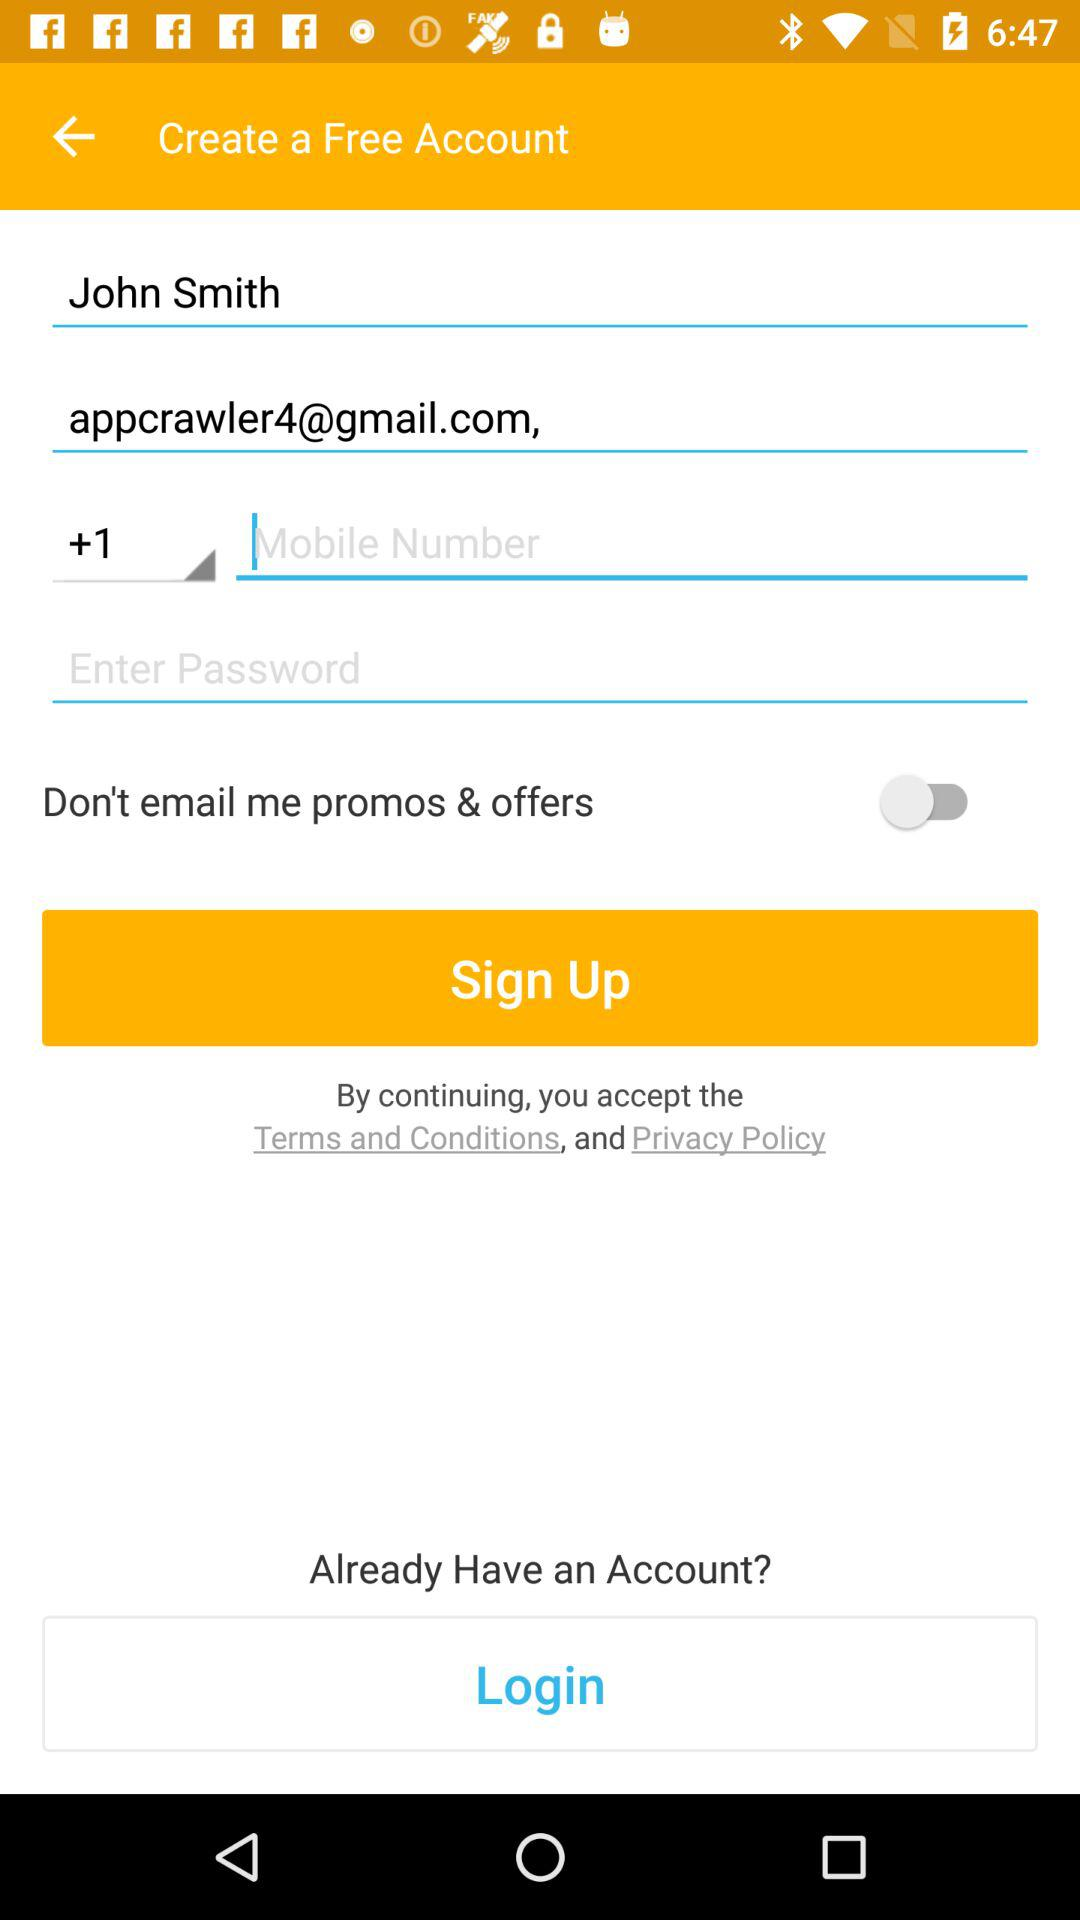How many characters are required to create a password?
When the provided information is insufficient, respond with <no answer>. <no answer> 